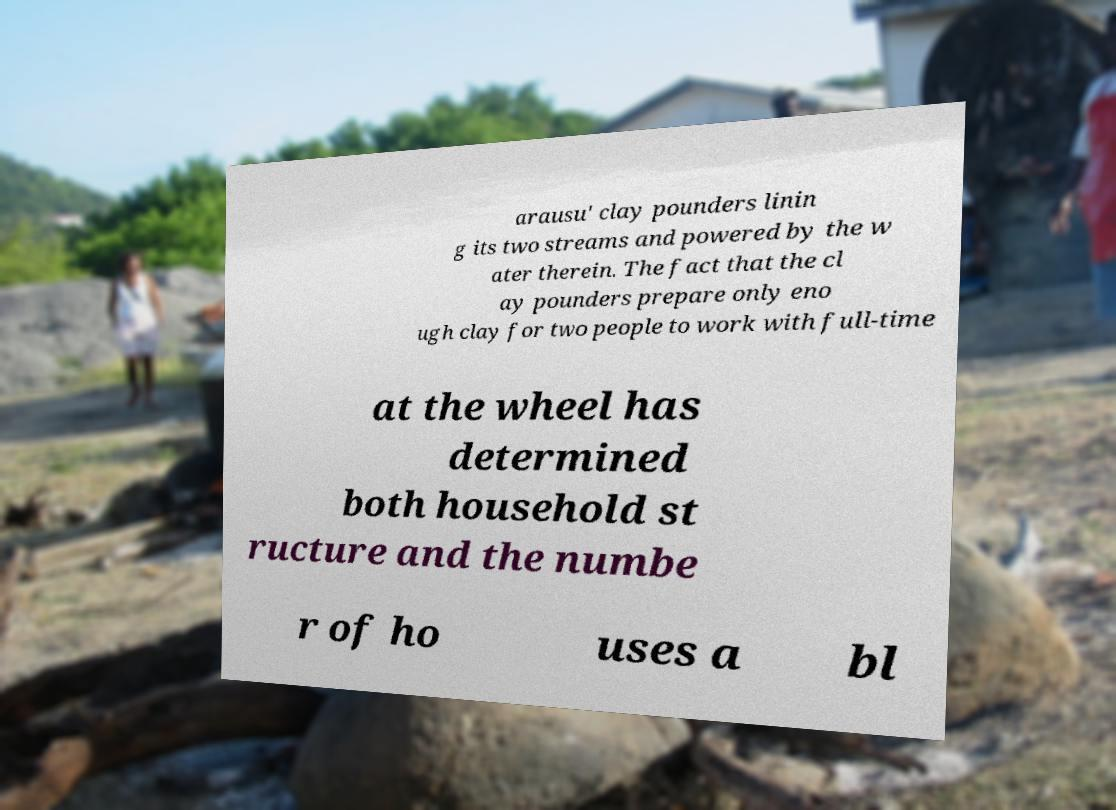What messages or text are displayed in this image? I need them in a readable, typed format. arausu' clay pounders linin g its two streams and powered by the w ater therein. The fact that the cl ay pounders prepare only eno ugh clay for two people to work with full-time at the wheel has determined both household st ructure and the numbe r of ho uses a bl 